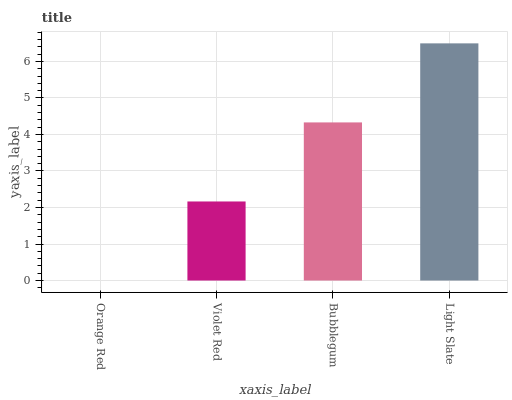Is Orange Red the minimum?
Answer yes or no. Yes. Is Light Slate the maximum?
Answer yes or no. Yes. Is Violet Red the minimum?
Answer yes or no. No. Is Violet Red the maximum?
Answer yes or no. No. Is Violet Red greater than Orange Red?
Answer yes or no. Yes. Is Orange Red less than Violet Red?
Answer yes or no. Yes. Is Orange Red greater than Violet Red?
Answer yes or no. No. Is Violet Red less than Orange Red?
Answer yes or no. No. Is Bubblegum the high median?
Answer yes or no. Yes. Is Violet Red the low median?
Answer yes or no. Yes. Is Orange Red the high median?
Answer yes or no. No. Is Light Slate the low median?
Answer yes or no. No. 